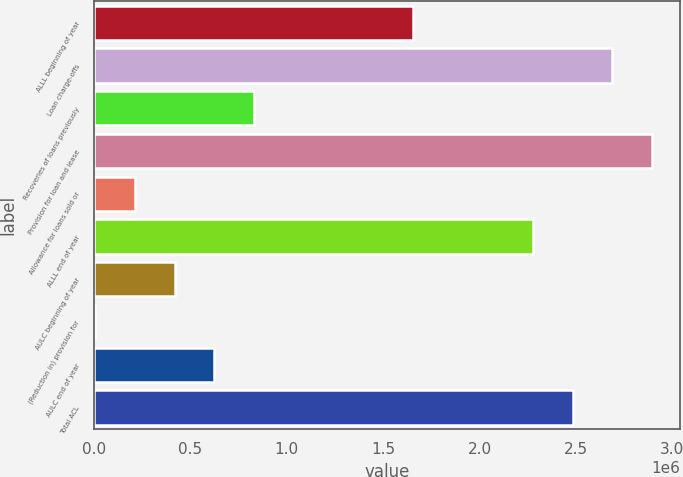<chart> <loc_0><loc_0><loc_500><loc_500><bar_chart><fcel>ALLL beginning of year<fcel>Loan charge-offs<fcel>Recoveries of loans previously<fcel>Provision for loan and lease<fcel>Allowance for loans sold or<fcel>ALLL end of year<fcel>AULC beginning of year<fcel>(Reduction in) provision for<fcel>AULC end of year<fcel>Total ACL<nl><fcel>1.65689e+06<fcel>2.68949e+06<fcel>830816<fcel>2.89601e+06<fcel>211259<fcel>2.27645e+06<fcel>417778<fcel>4740<fcel>624297<fcel>2.48297e+06<nl></chart> 